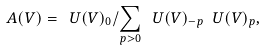Convert formula to latex. <formula><loc_0><loc_0><loc_500><loc_500>\ A ( V ) = \ U ( V ) _ { 0 } / \sum _ { p > 0 } \ U ( V ) _ { - p } \ U ( V ) _ { p } ,</formula> 